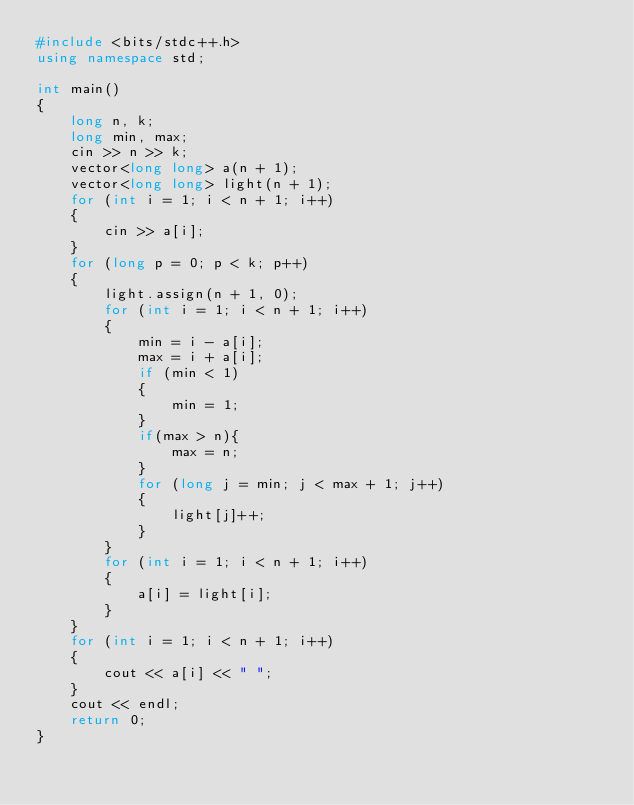<code> <loc_0><loc_0><loc_500><loc_500><_C++_>#include <bits/stdc++.h>
using namespace std;

int main()
{
    long n, k;
    long min, max;
    cin >> n >> k;
    vector<long long> a(n + 1);
    vector<long long> light(n + 1);
    for (int i = 1; i < n + 1; i++)
    {
        cin >> a[i];
    }
    for (long p = 0; p < k; p++)
    {
        light.assign(n + 1, 0);
        for (int i = 1; i < n + 1; i++)
        {
            min = i - a[i];
            max = i + a[i];
            if (min < 1)
            {
                min = 1;
            }
            if(max > n){
                max = n;
            }
            for (long j = min; j < max + 1; j++)
            {
                light[j]++;
            }
        }
        for (int i = 1; i < n + 1; i++)
        {
            a[i] = light[i];
        }
    }
    for (int i = 1; i < n + 1; i++)
    {
        cout << a[i] << " ";
    }
    cout << endl;
    return 0;
}</code> 